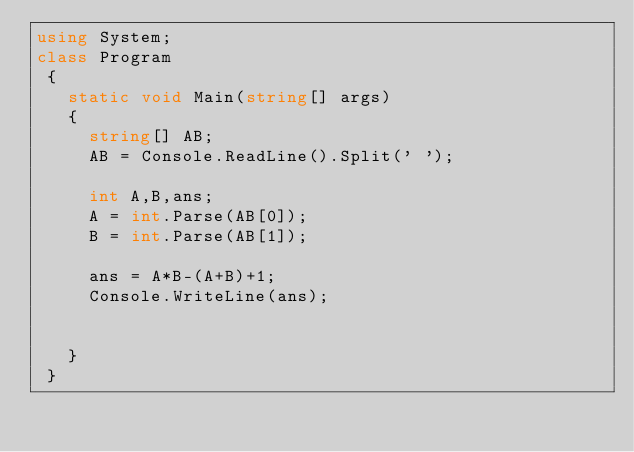<code> <loc_0><loc_0><loc_500><loc_500><_C#_>using System;
class Program
 {
   static void Main(string[] args)
   {
     string[] AB;
     AB = Console.ReadLine().Split(' ');

     int A,B,ans;
     A = int.Parse(AB[0]);
     B = int.Parse(AB[1]);

     ans = A*B-(A+B)+1;
     Console.WriteLine(ans);
     
         
   }
 }</code> 